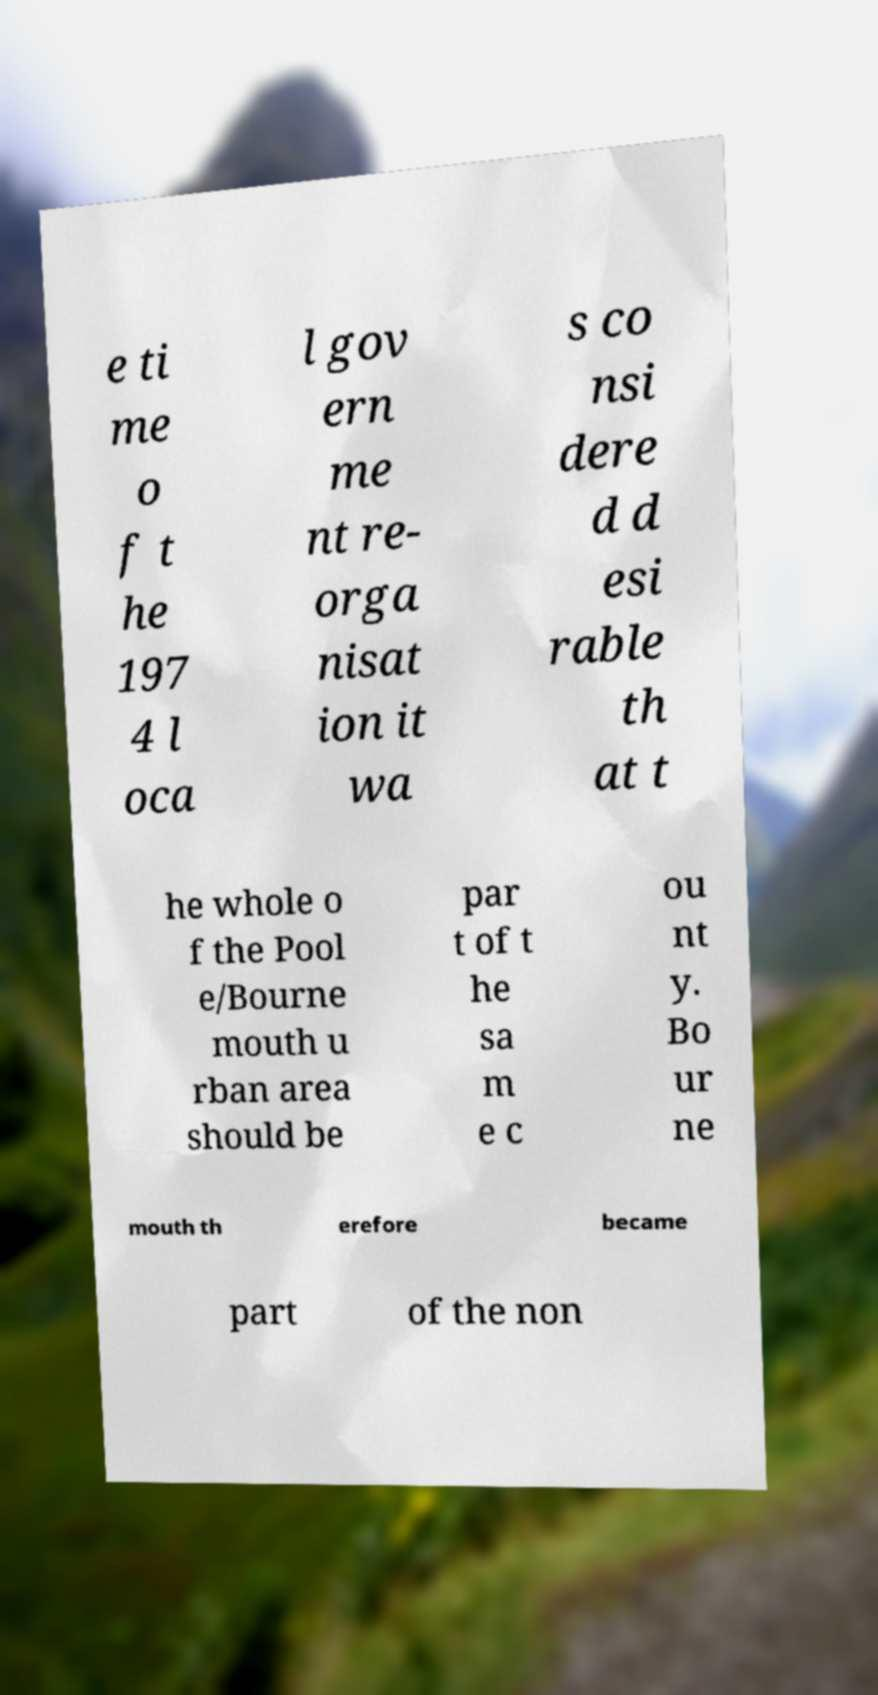For documentation purposes, I need the text within this image transcribed. Could you provide that? e ti me o f t he 197 4 l oca l gov ern me nt re- orga nisat ion it wa s co nsi dere d d esi rable th at t he whole o f the Pool e/Bourne mouth u rban area should be par t of t he sa m e c ou nt y. Bo ur ne mouth th erefore became part of the non 